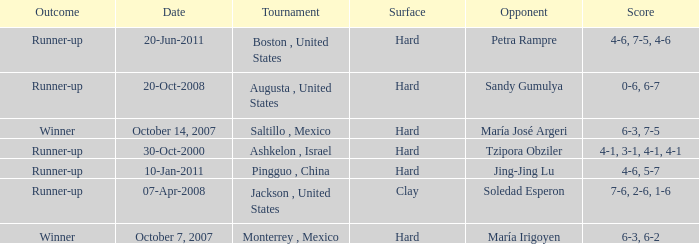Would you mind parsing the complete table? {'header': ['Outcome', 'Date', 'Tournament', 'Surface', 'Opponent', 'Score'], 'rows': [['Runner-up', '20-Jun-2011', 'Boston , United States', 'Hard', 'Petra Rampre', '4-6, 7-5, 4-6'], ['Runner-up', '20-Oct-2008', 'Augusta , United States', 'Hard', 'Sandy Gumulya', '0-6, 6-7'], ['Winner', 'October 14, 2007', 'Saltillo , Mexico', 'Hard', 'María José Argeri', '6-3, 7-5'], ['Runner-up', '30-Oct-2000', 'Ashkelon , Israel', 'Hard', 'Tzipora Obziler', '4-1, 3-1, 4-1, 4-1'], ['Runner-up', '10-Jan-2011', 'Pingguo , China', 'Hard', 'Jing-Jing Lu', '4-6, 5-7'], ['Runner-up', '07-Apr-2008', 'Jackson , United States', 'Clay', 'Soledad Esperon', '7-6, 2-6, 1-6'], ['Winner', 'October 7, 2007', 'Monterrey , Mexico', 'Hard', 'María Irigoyen', '6-3, 6-2']]} What was the outcome when Jing-Jing Lu was the opponent? Runner-up. 